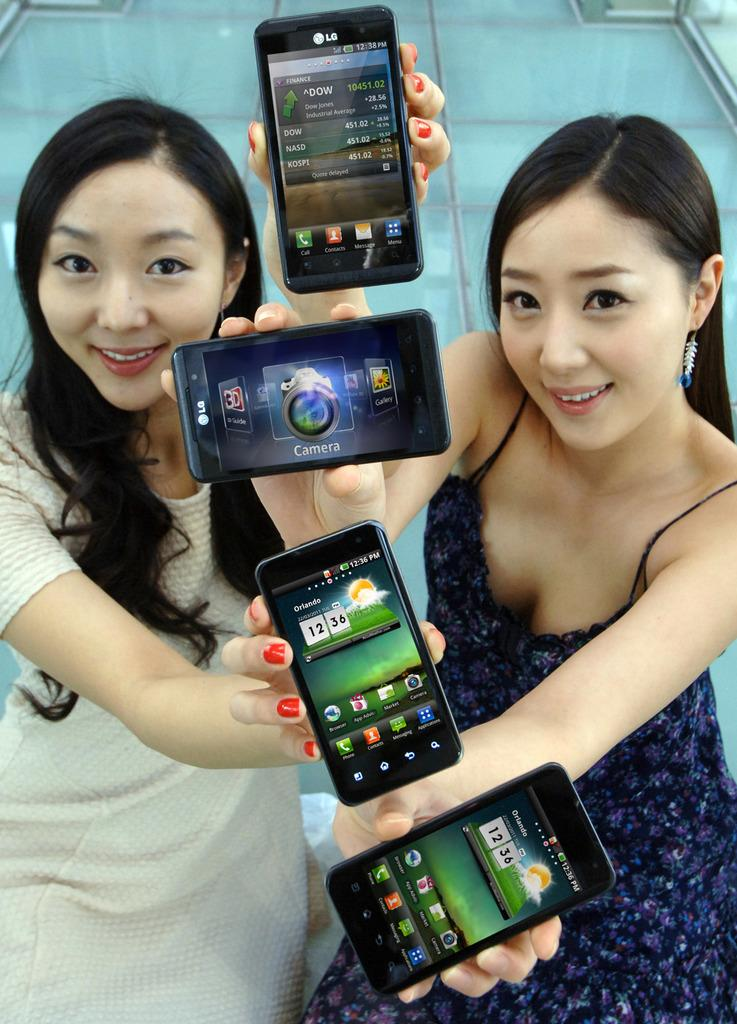<image>
Relay a brief, clear account of the picture shown. a couple girls holding phones with one that has 12:54 on it 